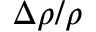Convert formula to latex. <formula><loc_0><loc_0><loc_500><loc_500>\Delta \rho / \rho</formula> 